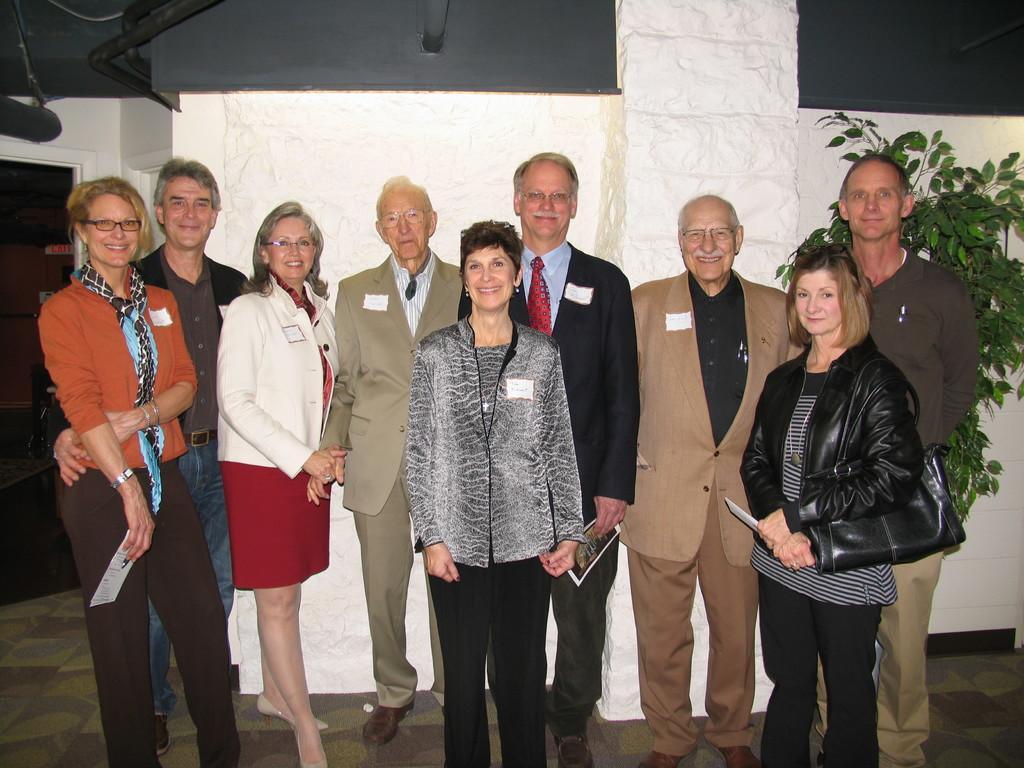Please provide a concise description of this image. In this image we can see many people standing. And some are holding something in the hand. One lady is holding a bag. In the back there is a plant and a wall. 